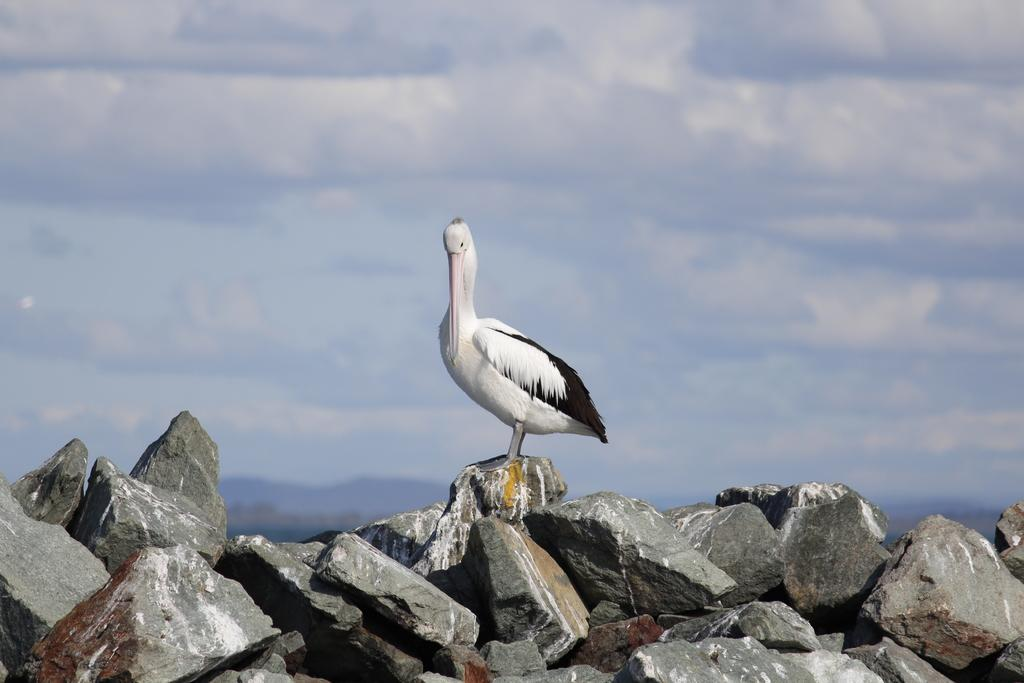What is the main subject of the image? The main subject of the image is a crane. What is the crane standing on? The crane is standing on a stone. What can be seen in the foreground of the image? There are stones in the foreground of the image. What is visible in the background of the image? There are mountains in the background of the image. What is visible at the top of the image? The sky is visible at the top of the image. What can be seen in the sky? There are clouds in the sky. What type of middle achiever can be seen in the image? There is no middle achiever present in the image; it features a crane standing on a stone with mountains and clouds in the background. What type of birds are flying around the crane in the image? There are no birds visible in the image; it only features a crane, stones, mountains, and clouds. 